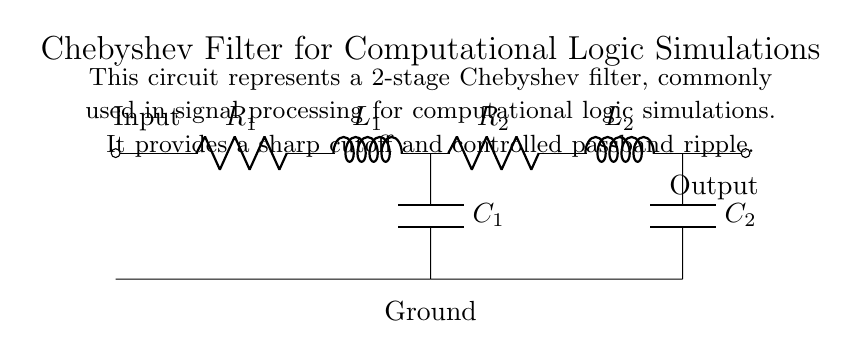What is the total number of stages in this filter? The circuit diagram indicates that there are two stages as identified by the two groups of components connected sequentially to process the signal input into output. Each stage consists of a combination of resistors, inductors, and capacitors working together.
Answer: Two What is the value of the inductor in the first stage? The first inductor in the circuit is labeled as L one, which represents its position in the cascading filter setup. The specific value is not provided in the diagram but is indicated by the labeling.
Answer: L one Which component provides the output from this circuit? The output of the circuit is indicated by the component labeled with the short output symbol at the right end of the circuit, which shows where the processed signal is sent out.
Answer: Output What is the purpose of using a Chebyshev filter in this circuit? A Chebyshev filter is designed to provide a sharp cutoff frequency while allowing a controlled amount of ripple within the passband. This is essential for ensuring that only the desired frequency components are preserved, making it suitable for signal processing applications in computational logic simulations.
Answer: Sharp cutoff How many capacitors are present in the circuit? By examining the circuit diagram, there are two capacitors, labeled as C one and C two, that correspond to each of the two filter stages. Each stage has a capacitor that completes the filtering process.
Answer: Two What function does the resistor in the second stage serve? The resistor in the second stage is part of the RLC network that defines the response characteristics of the filter, contributing to the overall impedance and frequency response of the filter. Its role is critical in controlling the behavior of the filter and shaping the output signal.
Answer: Impedance control 